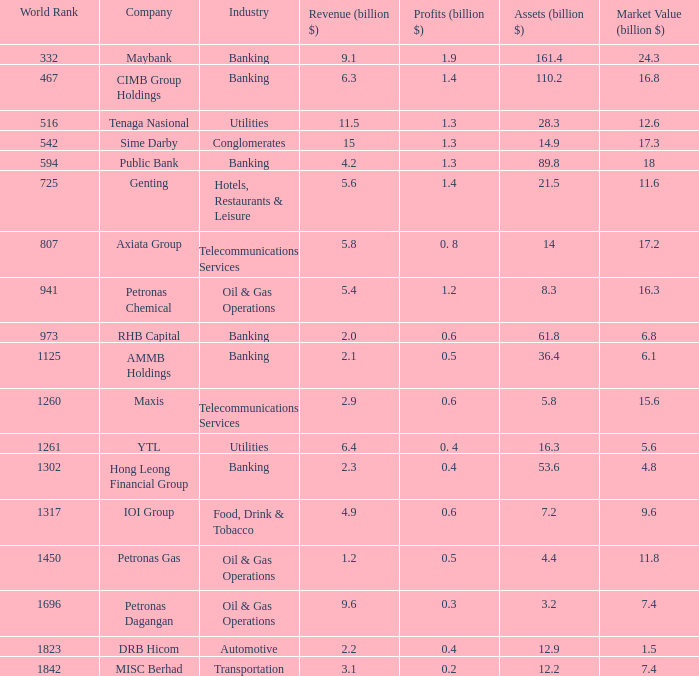Name the profits for market value of 11.8 0.5. 